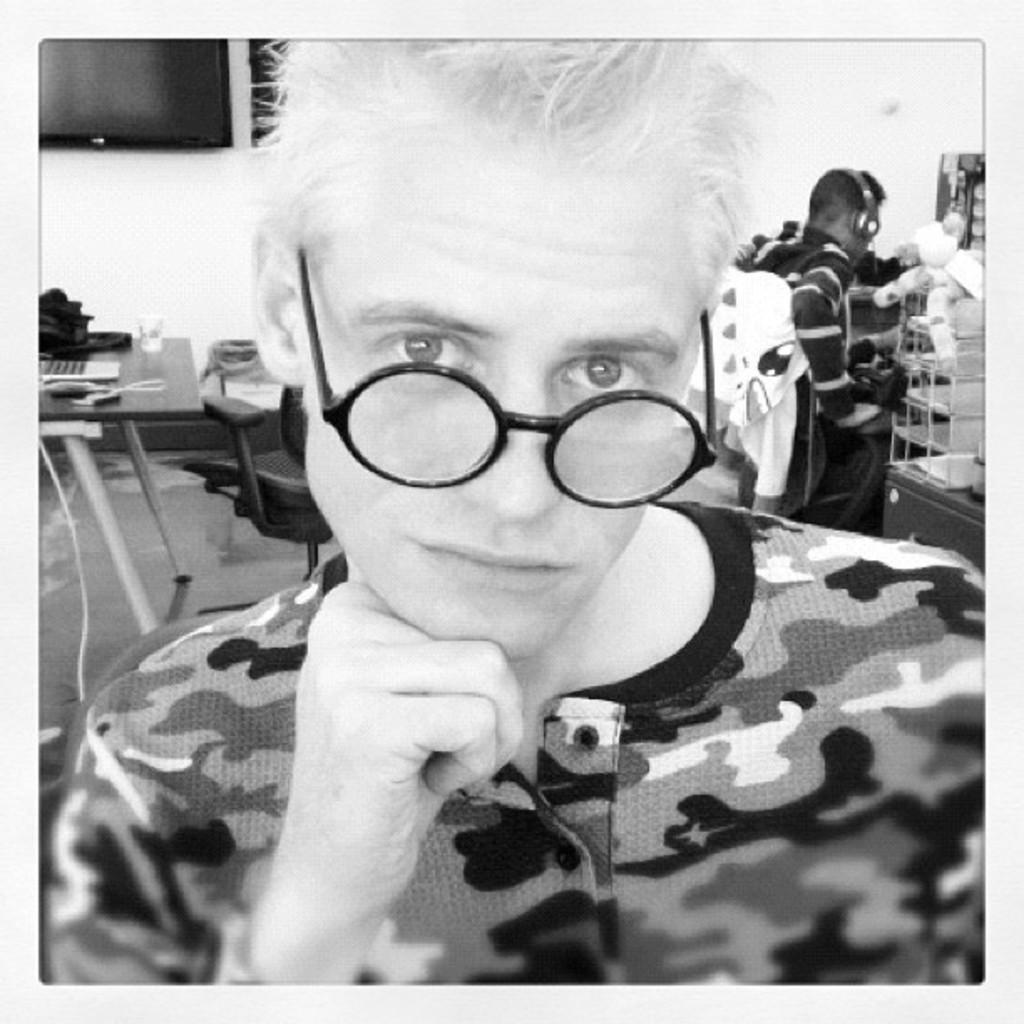In one or two sentences, can you explain what this image depicts? In the foreground of this black and white image, there is a man. Behind him, there is a laptop, bag, glass and few more objects on the table and there is a chair beside it. On the right, there is a man sitting on the chair wearing a headset and also there are few objects on the right. In the background, there is a wall and a screen. 